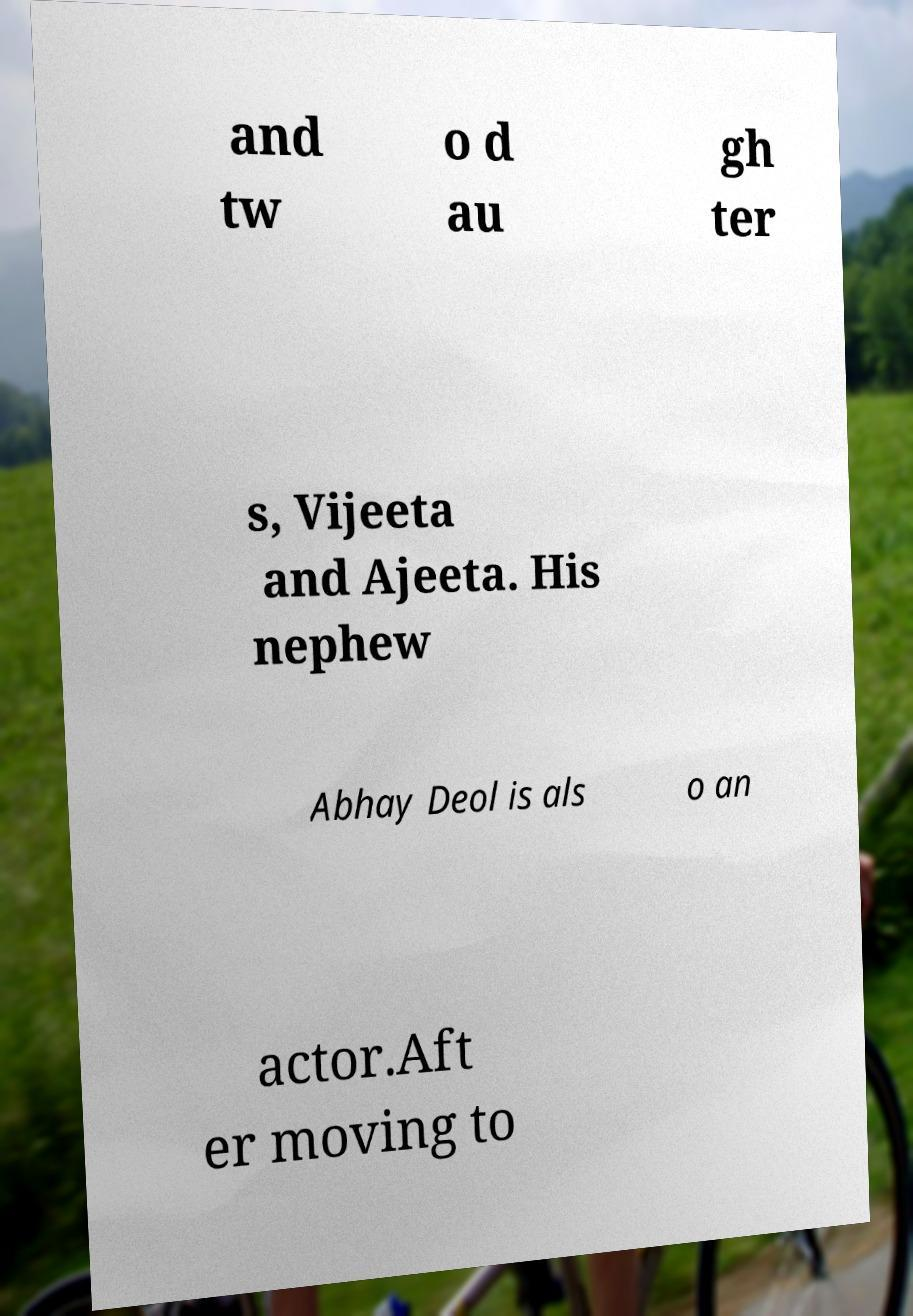Could you assist in decoding the text presented in this image and type it out clearly? and tw o d au gh ter s, Vijeeta and Ajeeta. His nephew Abhay Deol is als o an actor.Aft er moving to 